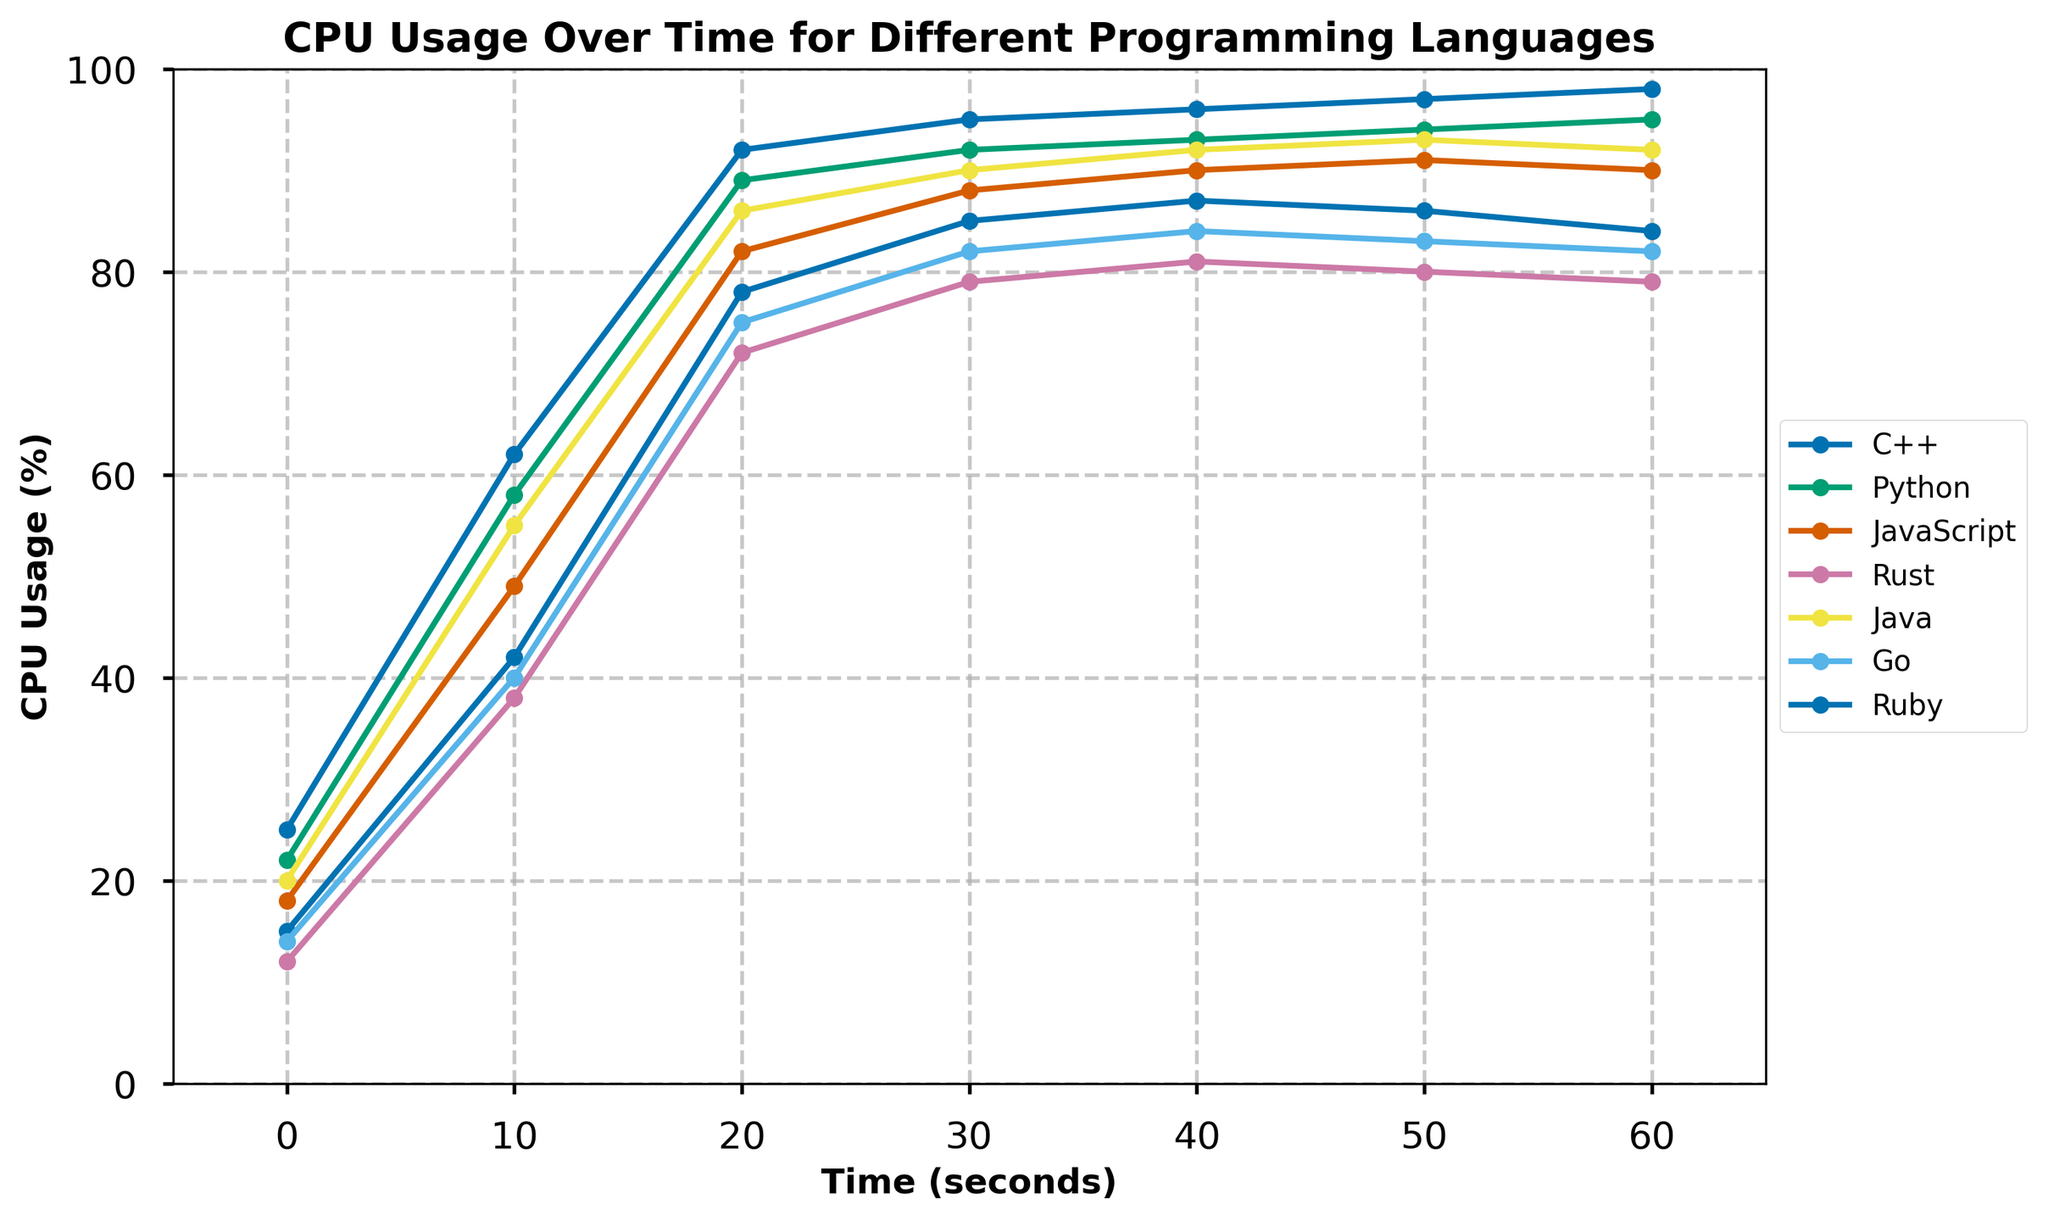What's the CPU usage of Python at 30 seconds? From the line chart, look for the data point corresponding to Python on the x-axis at 30s. Read the y-value of that point, which represents CPU usage.
Answer: 92% Which programming language has the highest CPU usage at 60 seconds? Observe the CPU usage values for each programming language at the 60s mark. The highest y-value among them is the maximum CPU usage.
Answer: Ruby How much does Go's CPU usage increase from 0 seconds to 60 seconds? Subtract Go's CPU usage value at 0s from the value at 60s: 82 - 14.
Answer: 68% Which two programming languages have nearly identical CPU usage at 40 seconds? Compare the CPU usage values for all programming languages at the 40s mark. JavaScript and Java both have nearly similar values.
Answer: JavaScript and Java What's the average CPU usage for Rust from 0 to 60 seconds? Compute the average of Rust's CPU usages at all time intervals: (12 + 38 + 72 + 79 + 81 + 80 + 79) / 7.
Answer: 63.0% Which language shows the sharpest increase in CPU usage from 0 to 10 seconds? Determine the CPU usage difference between 0s and 10s for each language. The largest value indicates the sharpest increase.
Answer: Python At what time does C++ reach its peak CPU usage? Identify the maximum CPU usage value for C++ and note the corresponding time on the x-axis.
Answer: 40 seconds For Python and Ruby, compare the CPU usages at 50 seconds. Which one is higher? Look up the CPU usage values for Python and Ruby at 50s. Compare these values to determine which is higher.
Answer: Ruby What is the total CPU usage for JavaScript from 0 to 60 seconds? Sum up JavaScript's CPU usage values at all the given time intervals: 18 + 49 + 82 + 88 + 90 + 91 + 90.
Answer: 508 What is the difference in CPU usage between Java and C++ at 20 seconds? Subtract C++'s CPU usage value at 20s from Java's CPU usage value at 20s.
Answer: 8% 